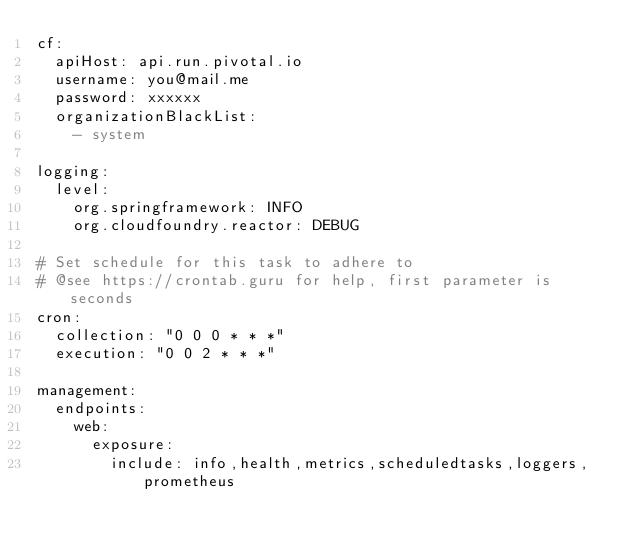Convert code to text. <code><loc_0><loc_0><loc_500><loc_500><_YAML_>cf:
  apiHost: api.run.pivotal.io
  username: you@mail.me
  password: xxxxxx
  organizationBlackList:
    - system

logging:
  level:
    org.springframework: INFO
    org.cloudfoundry.reactor: DEBUG

# Set schedule for this task to adhere to
# @see https://crontab.guru for help, first parameter is seconds
cron:
  collection: "0 0 0 * * *"
  execution: "0 0 2 * * *"

management:
  endpoints:
    web:
      exposure:
        include: info,health,metrics,scheduledtasks,loggers,prometheus
</code> 